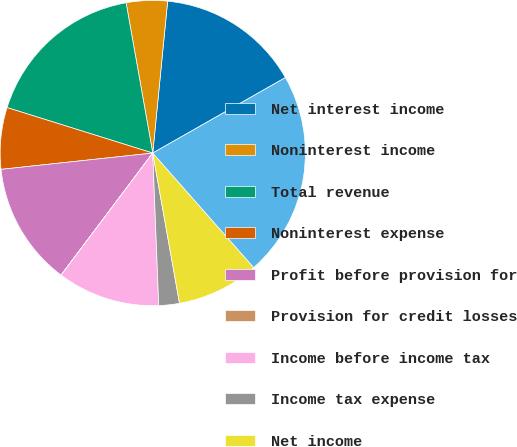Convert chart. <chart><loc_0><loc_0><loc_500><loc_500><pie_chart><fcel>Net interest income<fcel>Noninterest income<fcel>Total revenue<fcel>Noninterest expense<fcel>Profit before provision for<fcel>Provision for credit losses<fcel>Income before income tax<fcel>Income tax expense<fcel>Net income<fcel>Loans and leases and loans<nl><fcel>15.21%<fcel>4.35%<fcel>17.39%<fcel>6.52%<fcel>13.04%<fcel>0.01%<fcel>10.87%<fcel>2.18%<fcel>8.7%<fcel>21.73%<nl></chart> 